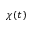Convert formula to latex. <formula><loc_0><loc_0><loc_500><loc_500>\chi ( t )</formula> 